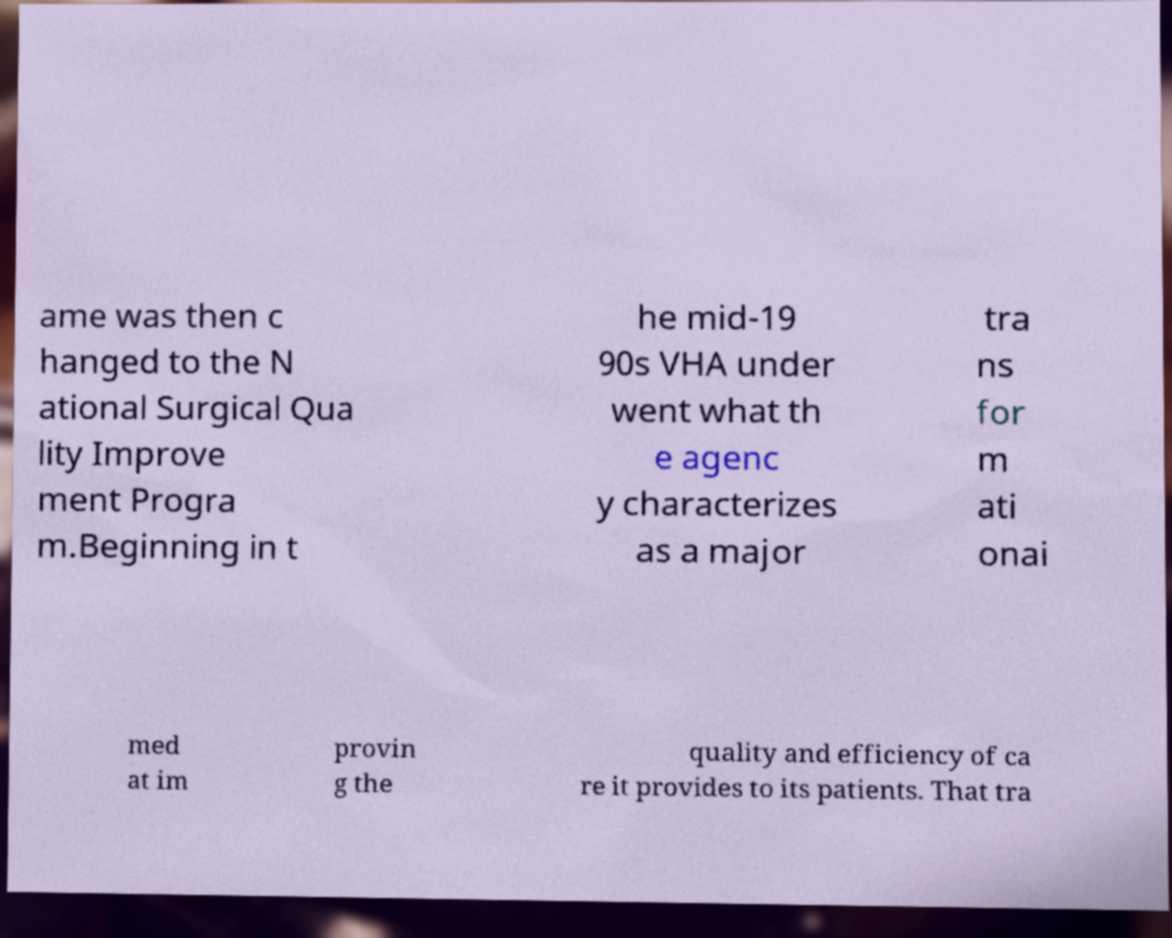I need the written content from this picture converted into text. Can you do that? ame was then c hanged to the N ational Surgical Qua lity Improve ment Progra m.Beginning in t he mid-19 90s VHA under went what th e agenc y characterizes as a major tra ns for m ati onai med at im provin g the quality and efficiency of ca re it provides to its patients. That tra 